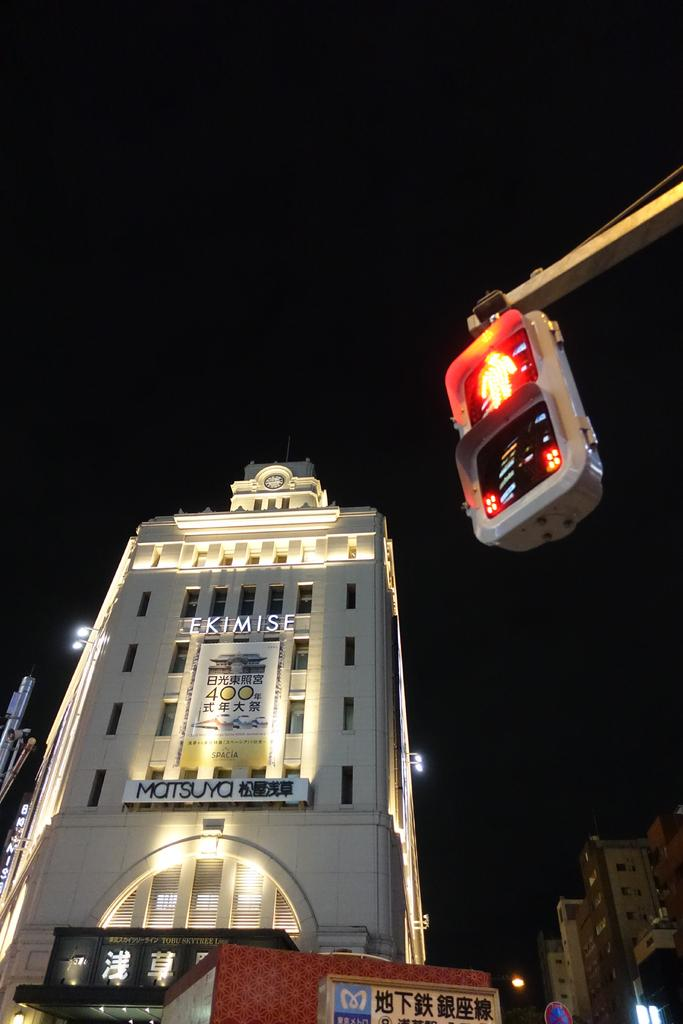<image>
Render a clear and concise summary of the photo. a huge white business with Chinese readings on them 